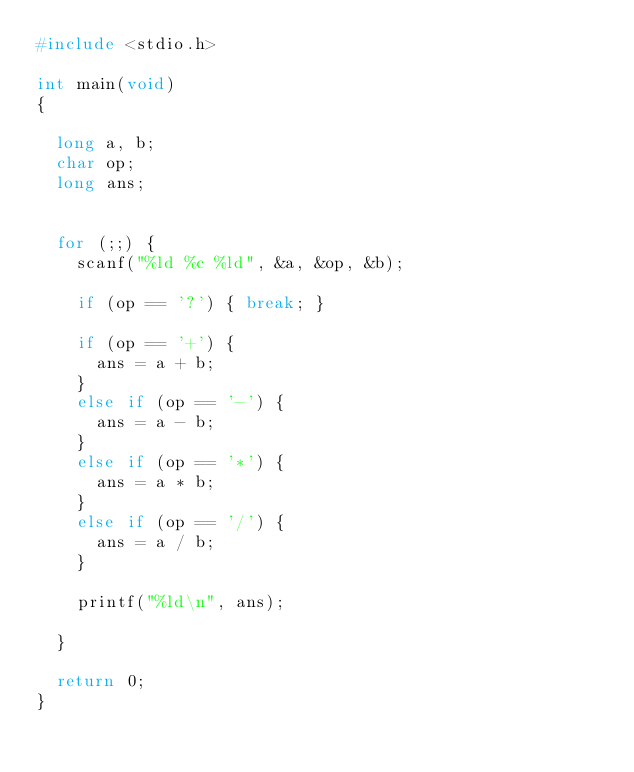Convert code to text. <code><loc_0><loc_0><loc_500><loc_500><_C_>#include <stdio.h>

int main(void)
{

	long a, b;
	char op;
	long ans;


	for (;;) {
		scanf("%ld %c %ld", &a, &op, &b);

		if (op == '?') { break; }

		if (op == '+') {
			ans = a + b;
		}
		else if (op == '-') {
			ans = a - b;
		}
		else if (op == '*') {
			ans = a * b;
		}
		else if (op == '/') {
			ans = a / b;
		}

		printf("%ld\n", ans);

	}

	return 0;
}</code> 